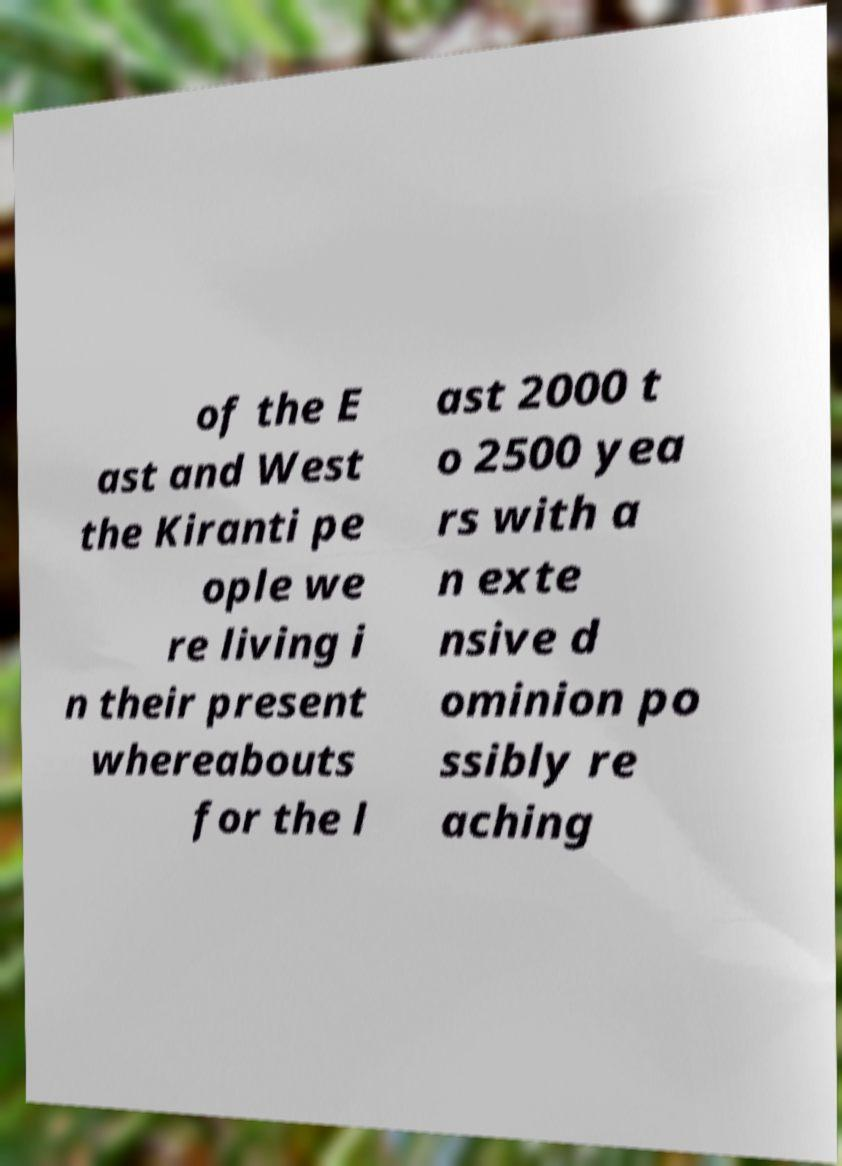For documentation purposes, I need the text within this image transcribed. Could you provide that? of the E ast and West the Kiranti pe ople we re living i n their present whereabouts for the l ast 2000 t o 2500 yea rs with a n exte nsive d ominion po ssibly re aching 